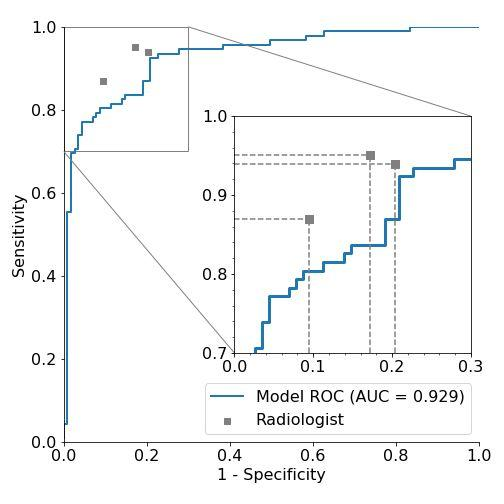Explain why there is a zoom-in section on the ROC curve and its importance. The zoom-in section on the ROC curve focuses on the region where specificity is between 0.6 and 0.9. This particular section is zoomed into because it demonstrates a critical area of performance where the differences between the model and the radiologist's predictions are most apparent. In practical terms, this zone could be where the model outperforms human evaluations significantly, particularly in handling true and false positives. This section might highlight where the model gains efficiency over traditional assessments, which can be crucial for understanding at what thresholds the model's accuracy becomes a significant improvement over human diagnostics. 